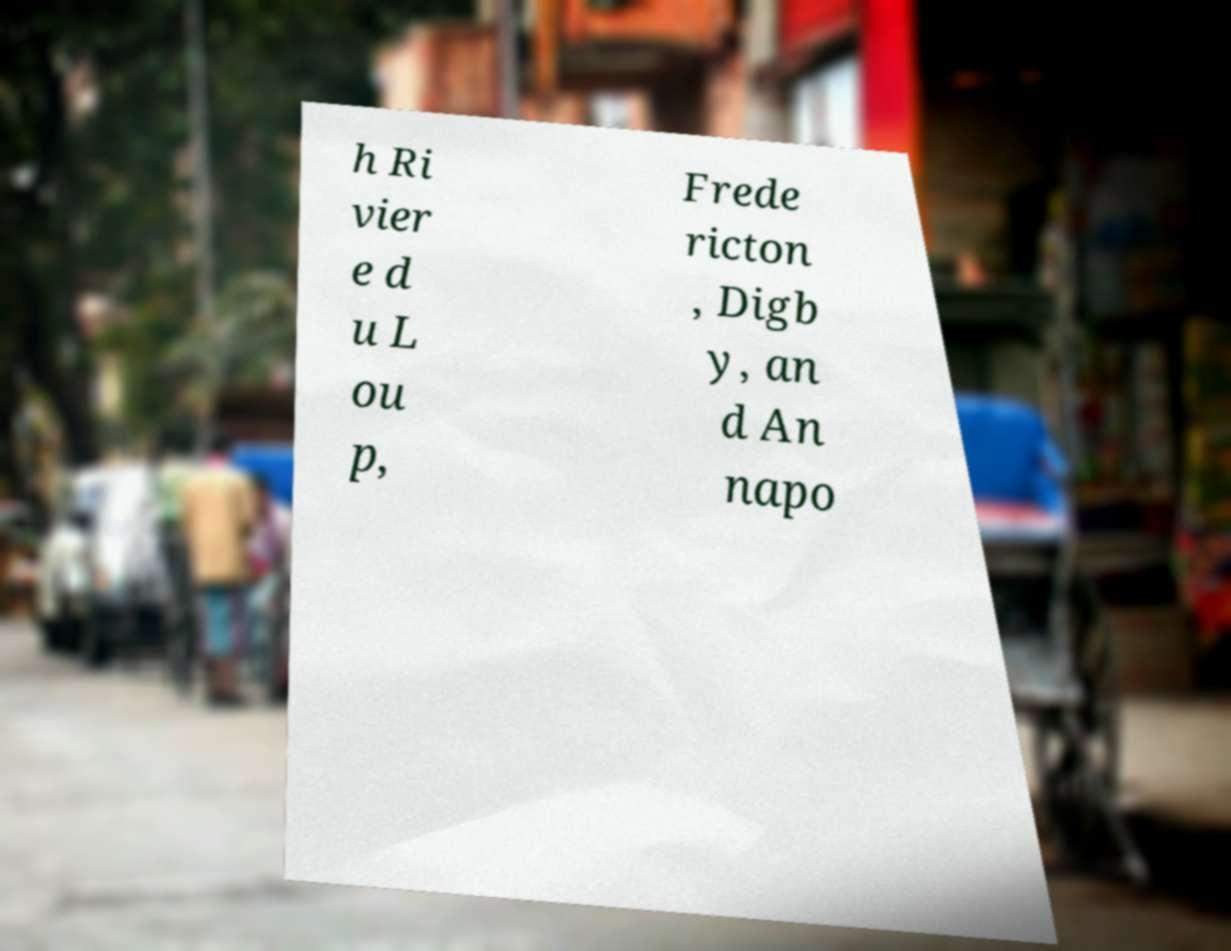What messages or text are displayed in this image? I need them in a readable, typed format. h Ri vier e d u L ou p, Frede ricton , Digb y, an d An napo 